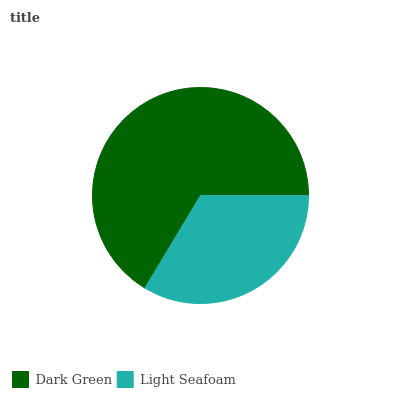Is Light Seafoam the minimum?
Answer yes or no. Yes. Is Dark Green the maximum?
Answer yes or no. Yes. Is Light Seafoam the maximum?
Answer yes or no. No. Is Dark Green greater than Light Seafoam?
Answer yes or no. Yes. Is Light Seafoam less than Dark Green?
Answer yes or no. Yes. Is Light Seafoam greater than Dark Green?
Answer yes or no. No. Is Dark Green less than Light Seafoam?
Answer yes or no. No. Is Dark Green the high median?
Answer yes or no. Yes. Is Light Seafoam the low median?
Answer yes or no. Yes. Is Light Seafoam the high median?
Answer yes or no. No. Is Dark Green the low median?
Answer yes or no. No. 